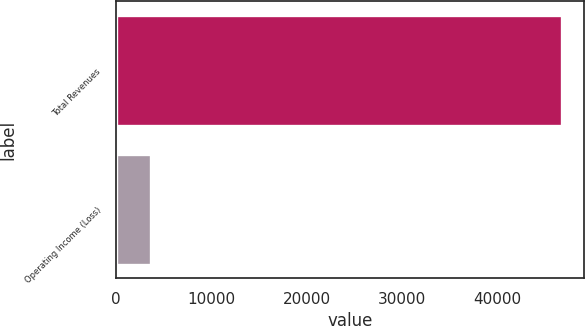Convert chart. <chart><loc_0><loc_0><loc_500><loc_500><bar_chart><fcel>Total Revenues<fcel>Operating Income (Loss)<nl><fcel>46723<fcel>3648<nl></chart> 